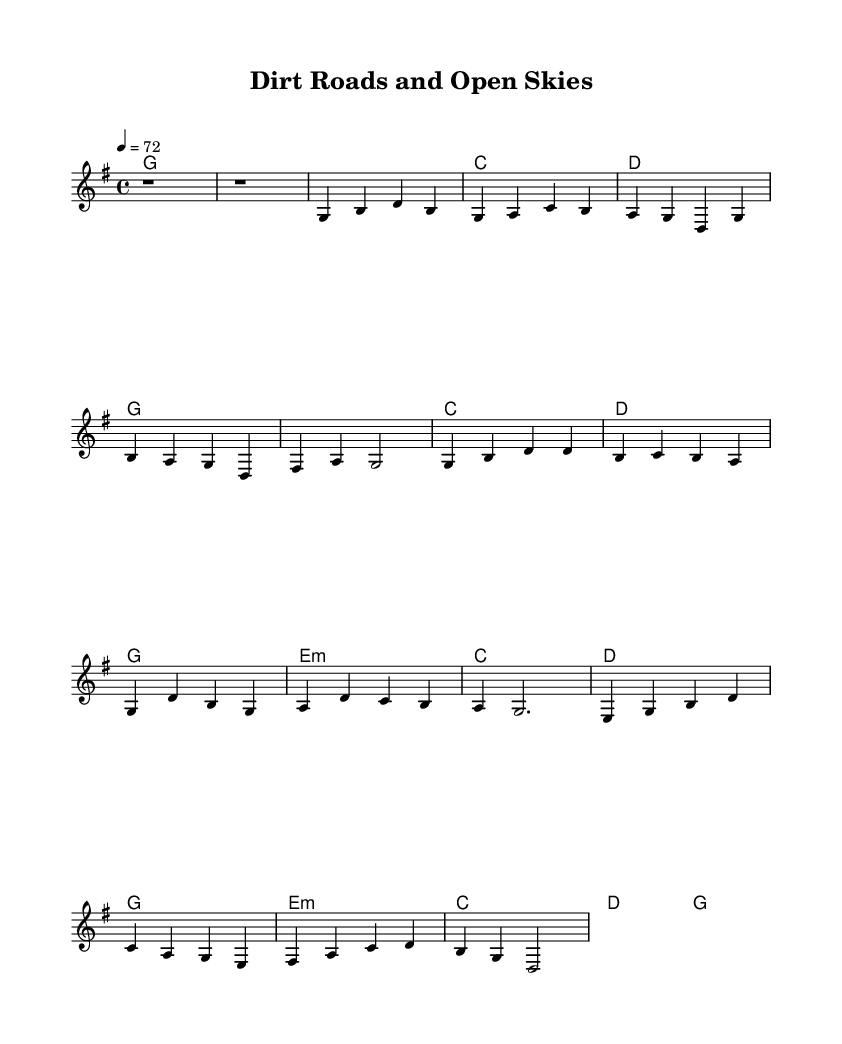What is the key signature of this music? The key signature is G major, which has one sharp (F#). This is determined by looking at the \key g \major command in the global section of the code.
Answer: G major What is the time signature of the music? The time signature is 4/4, which means there are four beats in each measure and the quarter note gets one beat. This is indicated by the \time 4/4 command in the global section of the code.
Answer: 4/4 What is the tempo marking of the piece? The tempo marking is 72 beats per minute. This can be found in the \tempo 4 = 72 command in the global section, signifying the speed at which the music should be played.
Answer: 72 What is the first chord in the piece? The first chord is G major. This is identified by looking at the first chord in the harmonies, which is designated as g1, indicating a G major chord underlying the music.
Answer: G major How many measures are there in the chorus section? The chorus section consists of four measures, which can be counted from the melody and harmonies defined under the Chorus in the code. Each line within the chorus section indicates a measure, and there are four distinct chord sequences and melody lines.
Answer: 4 What is the last note of the bridge section? The last note of the bridge section is D. This can be concluded by examining the melody line at the end of the bridge, which specifically marks b g d2, indicating that D is the last note played in that section.
Answer: D 